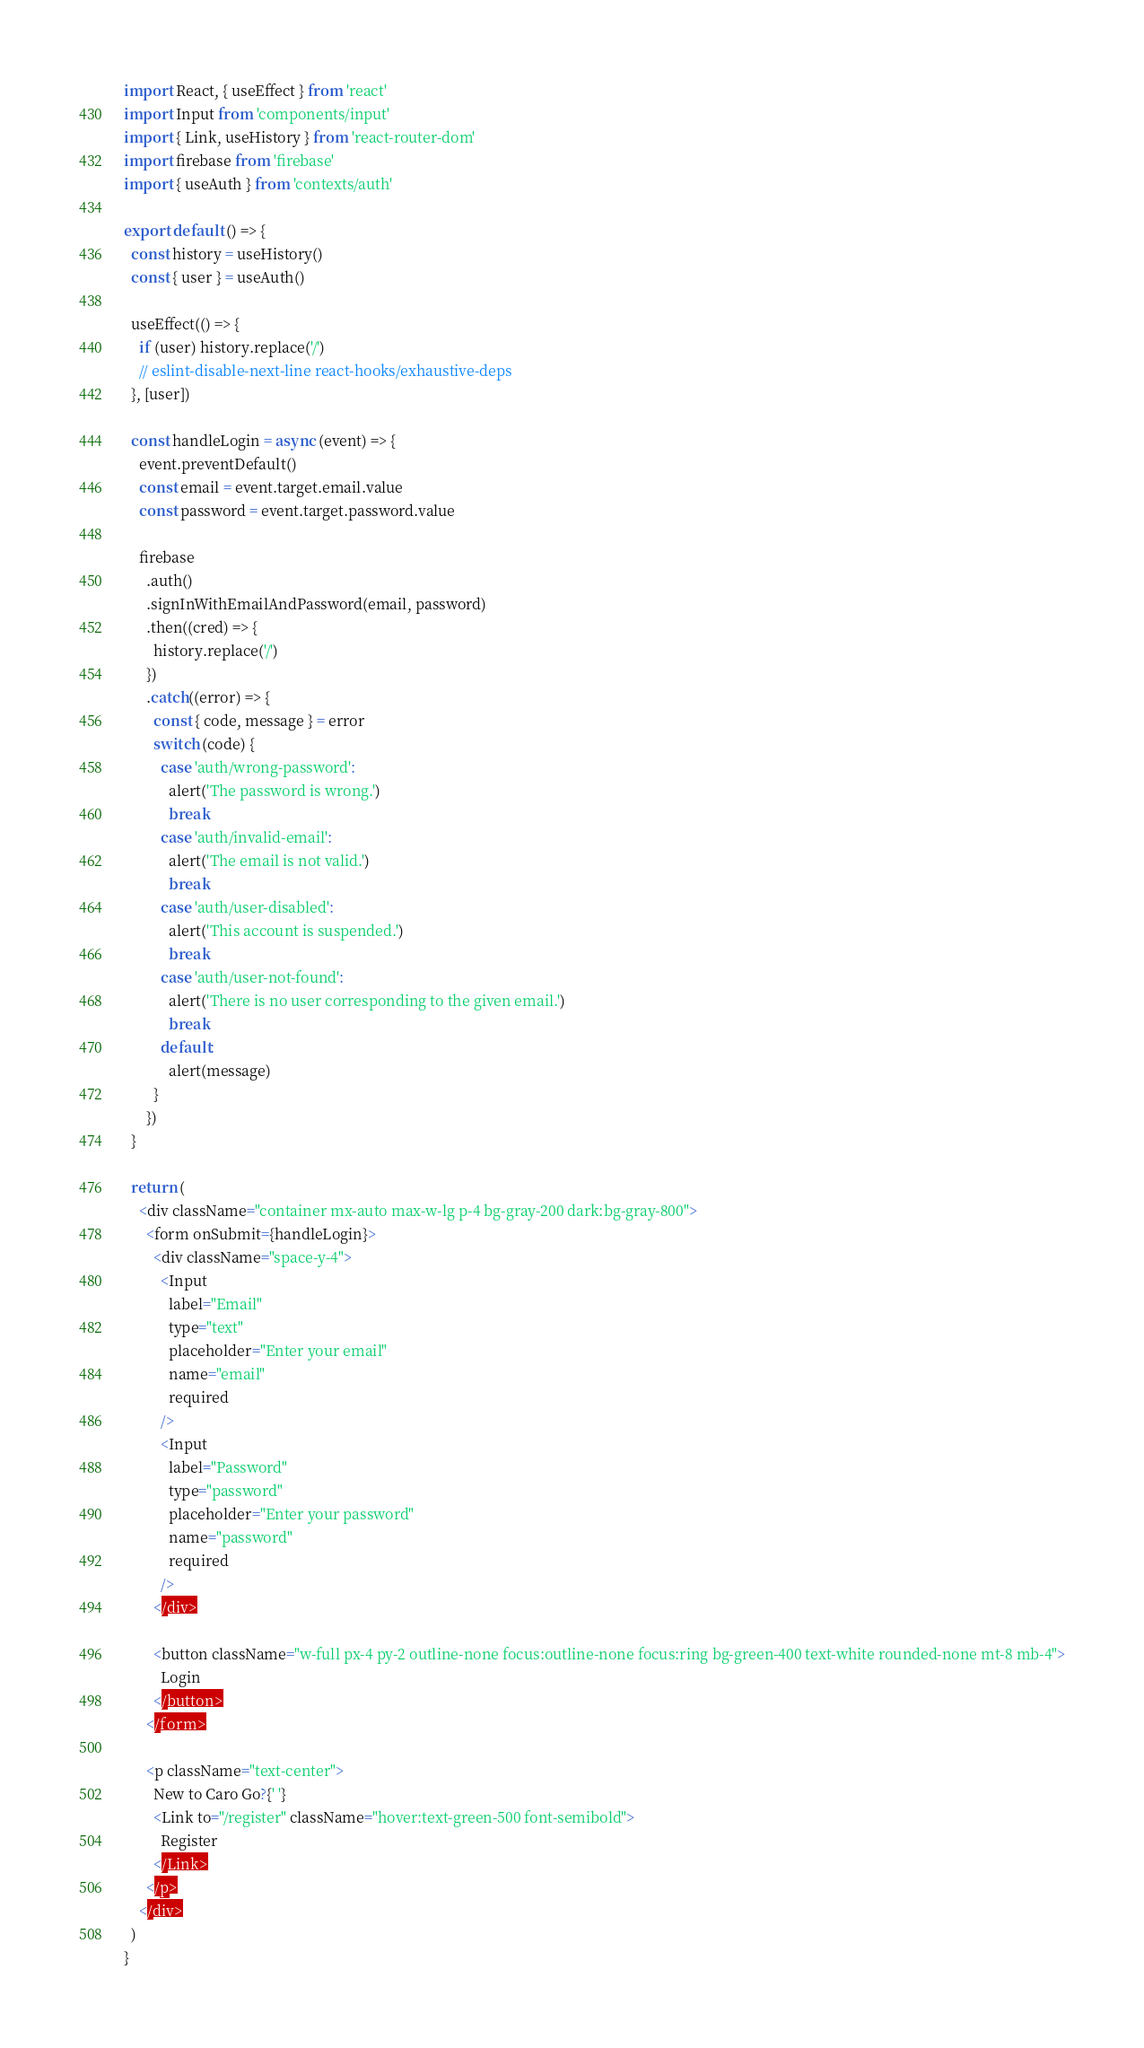<code> <loc_0><loc_0><loc_500><loc_500><_JavaScript_>import React, { useEffect } from 'react'
import Input from 'components/input'
import { Link, useHistory } from 'react-router-dom'
import firebase from 'firebase'
import { useAuth } from 'contexts/auth'

export default () => {
  const history = useHistory()
  const { user } = useAuth()

  useEffect(() => {
    if (user) history.replace('/')
    // eslint-disable-next-line react-hooks/exhaustive-deps
  }, [user])

  const handleLogin = async (event) => {
    event.preventDefault()
    const email = event.target.email.value
    const password = event.target.password.value

    firebase
      .auth()
      .signInWithEmailAndPassword(email, password)
      .then((cred) => {
        history.replace('/')
      })
      .catch((error) => {
        const { code, message } = error
        switch (code) {
          case 'auth/wrong-password':
            alert('The password is wrong.')
            break
          case 'auth/invalid-email':
            alert('The email is not valid.')
            break
          case 'auth/user-disabled':
            alert('This account is suspended.')
            break
          case 'auth/user-not-found':
            alert('There is no user corresponding to the given email.')
            break
          default:
            alert(message)
        }
      })
  }

  return (
    <div className="container mx-auto max-w-lg p-4 bg-gray-200 dark:bg-gray-800">
      <form onSubmit={handleLogin}>
        <div className="space-y-4">
          <Input
            label="Email"
            type="text"
            placeholder="Enter your email"
            name="email"
            required
          />
          <Input
            label="Password"
            type="password"
            placeholder="Enter your password"
            name="password"
            required
          />
        </div>

        <button className="w-full px-4 py-2 outline-none focus:outline-none focus:ring bg-green-400 text-white rounded-none mt-8 mb-4">
          Login
        </button>
      </form>

      <p className="text-center">
        New to Caro Go?{' '}
        <Link to="/register" className="hover:text-green-500 font-semibold">
          Register
        </Link>
      </p>
    </div>
  )
}
</code> 